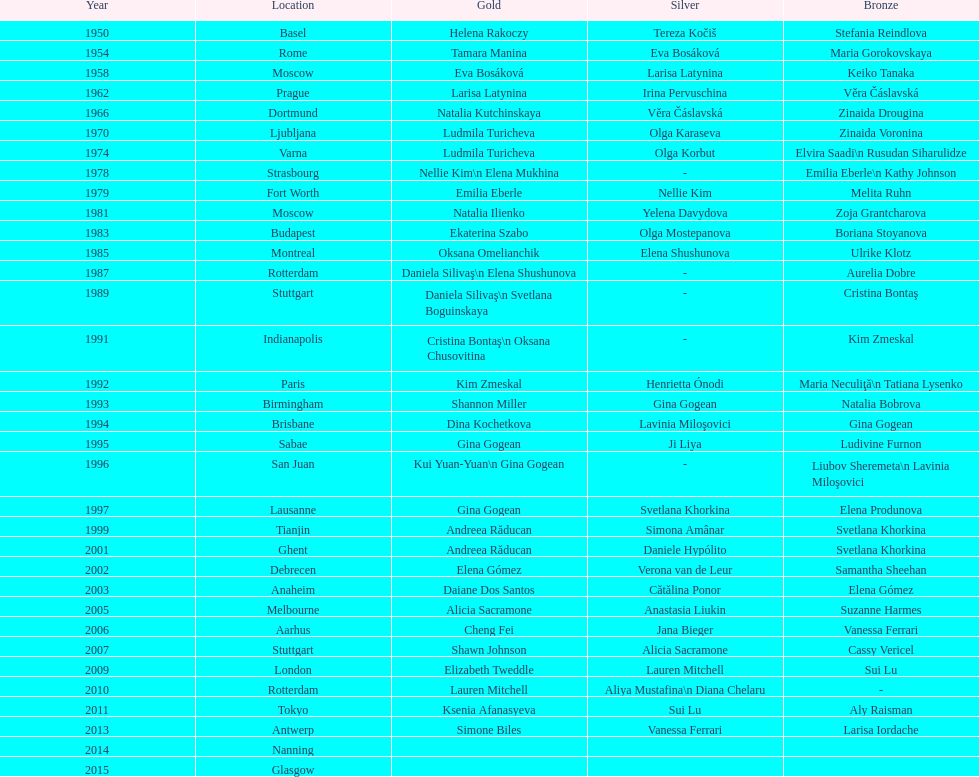Where did the world artistic gymnastics take place before san juan? Sabae. 